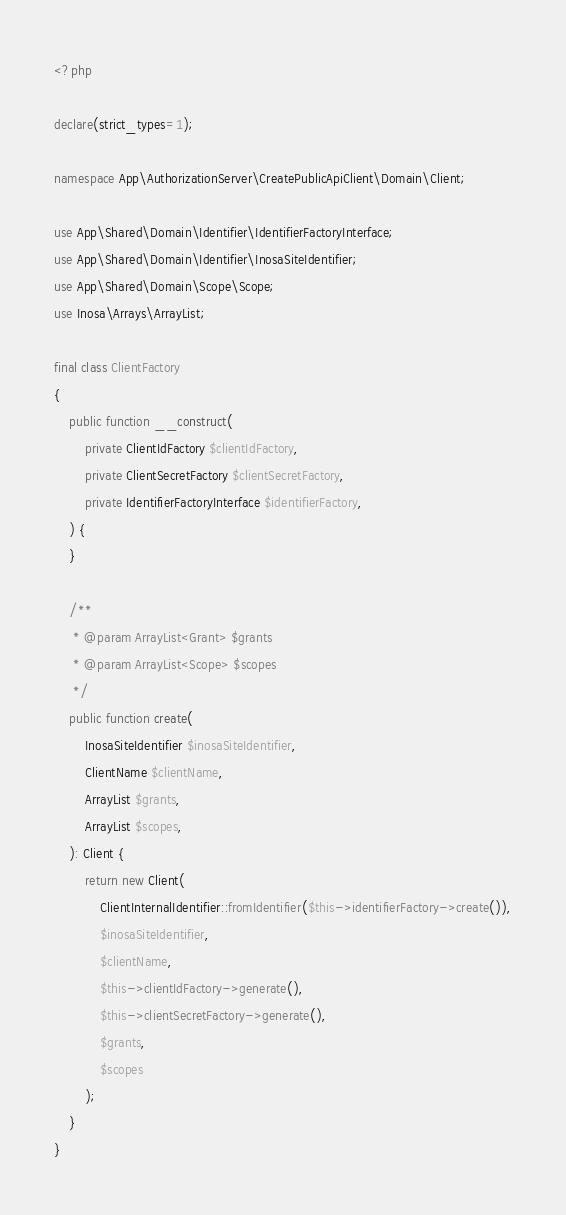Convert code to text. <code><loc_0><loc_0><loc_500><loc_500><_PHP_><?php

declare(strict_types=1);

namespace App\AuthorizationServer\CreatePublicApiClient\Domain\Client;

use App\Shared\Domain\Identifier\IdentifierFactoryInterface;
use App\Shared\Domain\Identifier\InosaSiteIdentifier;
use App\Shared\Domain\Scope\Scope;
use Inosa\Arrays\ArrayList;

final class ClientFactory
{
    public function __construct(
        private ClientIdFactory $clientIdFactory,
        private ClientSecretFactory $clientSecretFactory,
        private IdentifierFactoryInterface $identifierFactory,
    ) {
    }

    /**
     * @param ArrayList<Grant> $grants
     * @param ArrayList<Scope> $scopes
     */
    public function create(
        InosaSiteIdentifier $inosaSiteIdentifier,
        ClientName $clientName,
        ArrayList $grants,
        ArrayList $scopes,
    ): Client {
        return new Client(
            ClientInternalIdentifier::fromIdentifier($this->identifierFactory->create()),
            $inosaSiteIdentifier,
            $clientName,
            $this->clientIdFactory->generate(),
            $this->clientSecretFactory->generate(),
            $grants,
            $scopes
        );
    }
}
</code> 